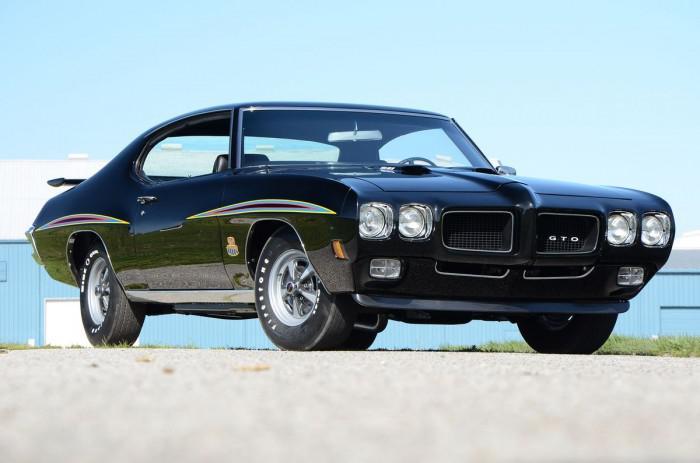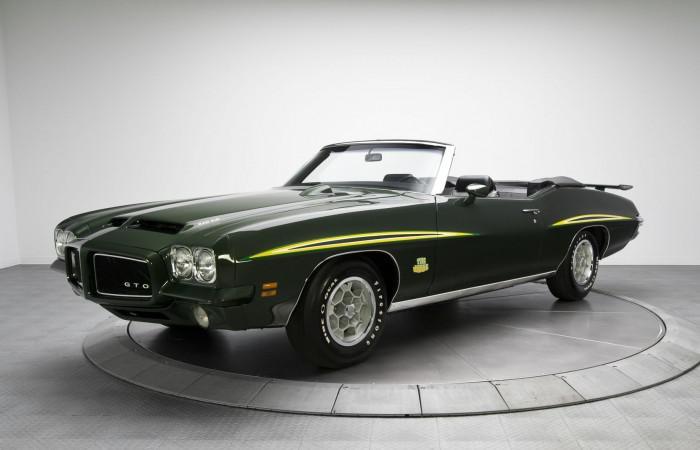The first image is the image on the left, the second image is the image on the right. For the images shown, is this caption "Both vehicles are convertibles." true? Answer yes or no. No. 